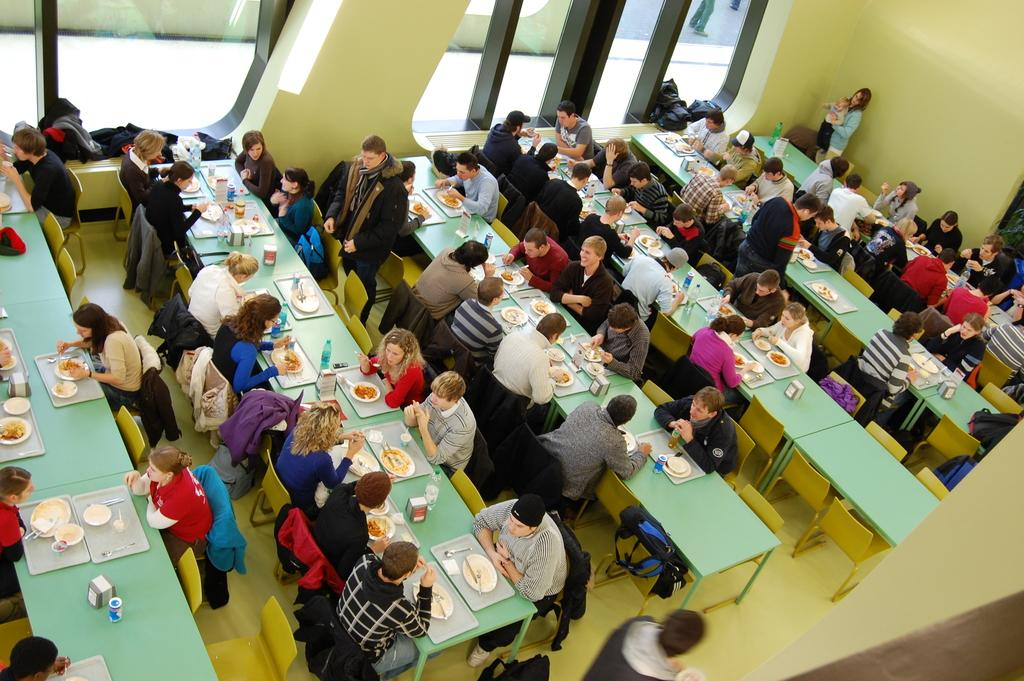What is the perspective of the image? The image shows a top view of a cafeteria. How many people can be seen in the cafeteria? There are many people in the cafeteria. What are the people doing in the image? The people are sitting on chairs. What activity are the people engaged in while sitting on chairs? The people are having food on their tables. What type of paper is being used to make oatmeal in the image? There is no oatmeal or paper present in the image; it shows a cafeteria with people sitting and having food on their tables. 